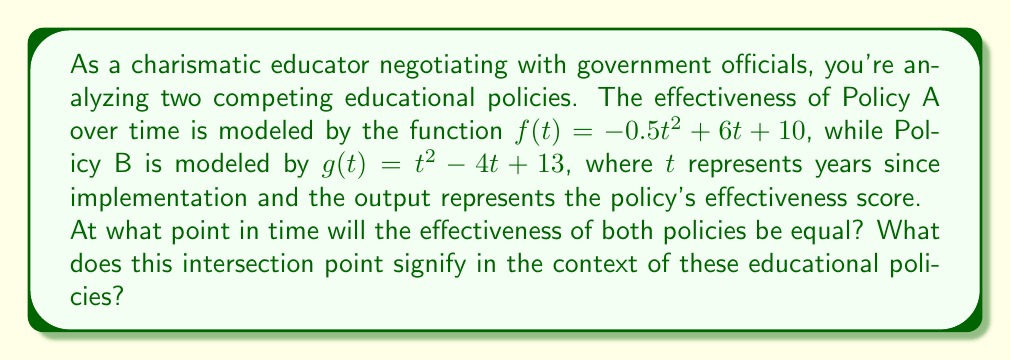Give your solution to this math problem. To solve this problem, we need to find the intersection point(s) of the two polynomial functions. This occurs when $f(t) = g(t)$.

1) Set up the equation:
   $-0.5t^2 + 6t + 10 = t^2 - 4t + 13$

2) Rearrange to standard form:
   $-0.5t^2 + 6t + 10 = t^2 - 4t + 13$
   $-1.5t^2 + 10t - 3 = 0$

3) Multiply all terms by -2 to simplify coefficients:
   $3t^2 - 20t + 6 = 0$

4) Use the quadratic formula to solve: $t = \frac{-b \pm \sqrt{b^2 - 4ac}}{2a}$
   Where $a = 3$, $b = -20$, and $c = 6$

   $$t = \frac{20 \pm \sqrt{(-20)^2 - 4(3)(6)}}{2(3)}$$
   $$t = \frac{20 \pm \sqrt{400 - 72}}{6}$$
   $$t = \frac{20 \pm \sqrt{328}}{6}$$
   $$t = \frac{20 \pm 18.11}{6}$$

5) This gives us two solutions:
   $t_1 = \frac{20 + 18.11}{6} \approx 6.35$ years
   $t_2 = \frac{20 - 18.11}{6} \approx 0.32$ years

The positive, realistic solution in this context is approximately 6.35 years after implementation.

This intersection point signifies the time at which both policies will have equal effectiveness scores. Before this point, one policy outperforms the other, and after this point, their relative performance switches. As an educator negotiating with government officials, this information is crucial for making informed decisions about which policy to support and when to potentially switch strategies.
Answer: The effectiveness of both policies will be equal approximately 6.35 years after implementation. This intersection point signifies the time at which the two educational policies have equal effectiveness scores, marking a critical juncture for policy evaluation and potential strategy adjustment. 